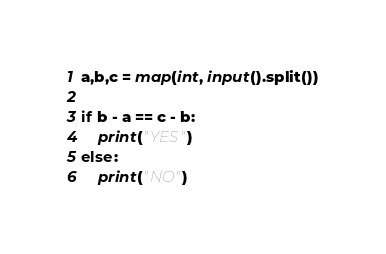Convert code to text. <code><loc_0><loc_0><loc_500><loc_500><_Python_>a,b,c = map(int, input().split())

if b - a == c - b:
    print("YES")
else:
    print("NO")</code> 